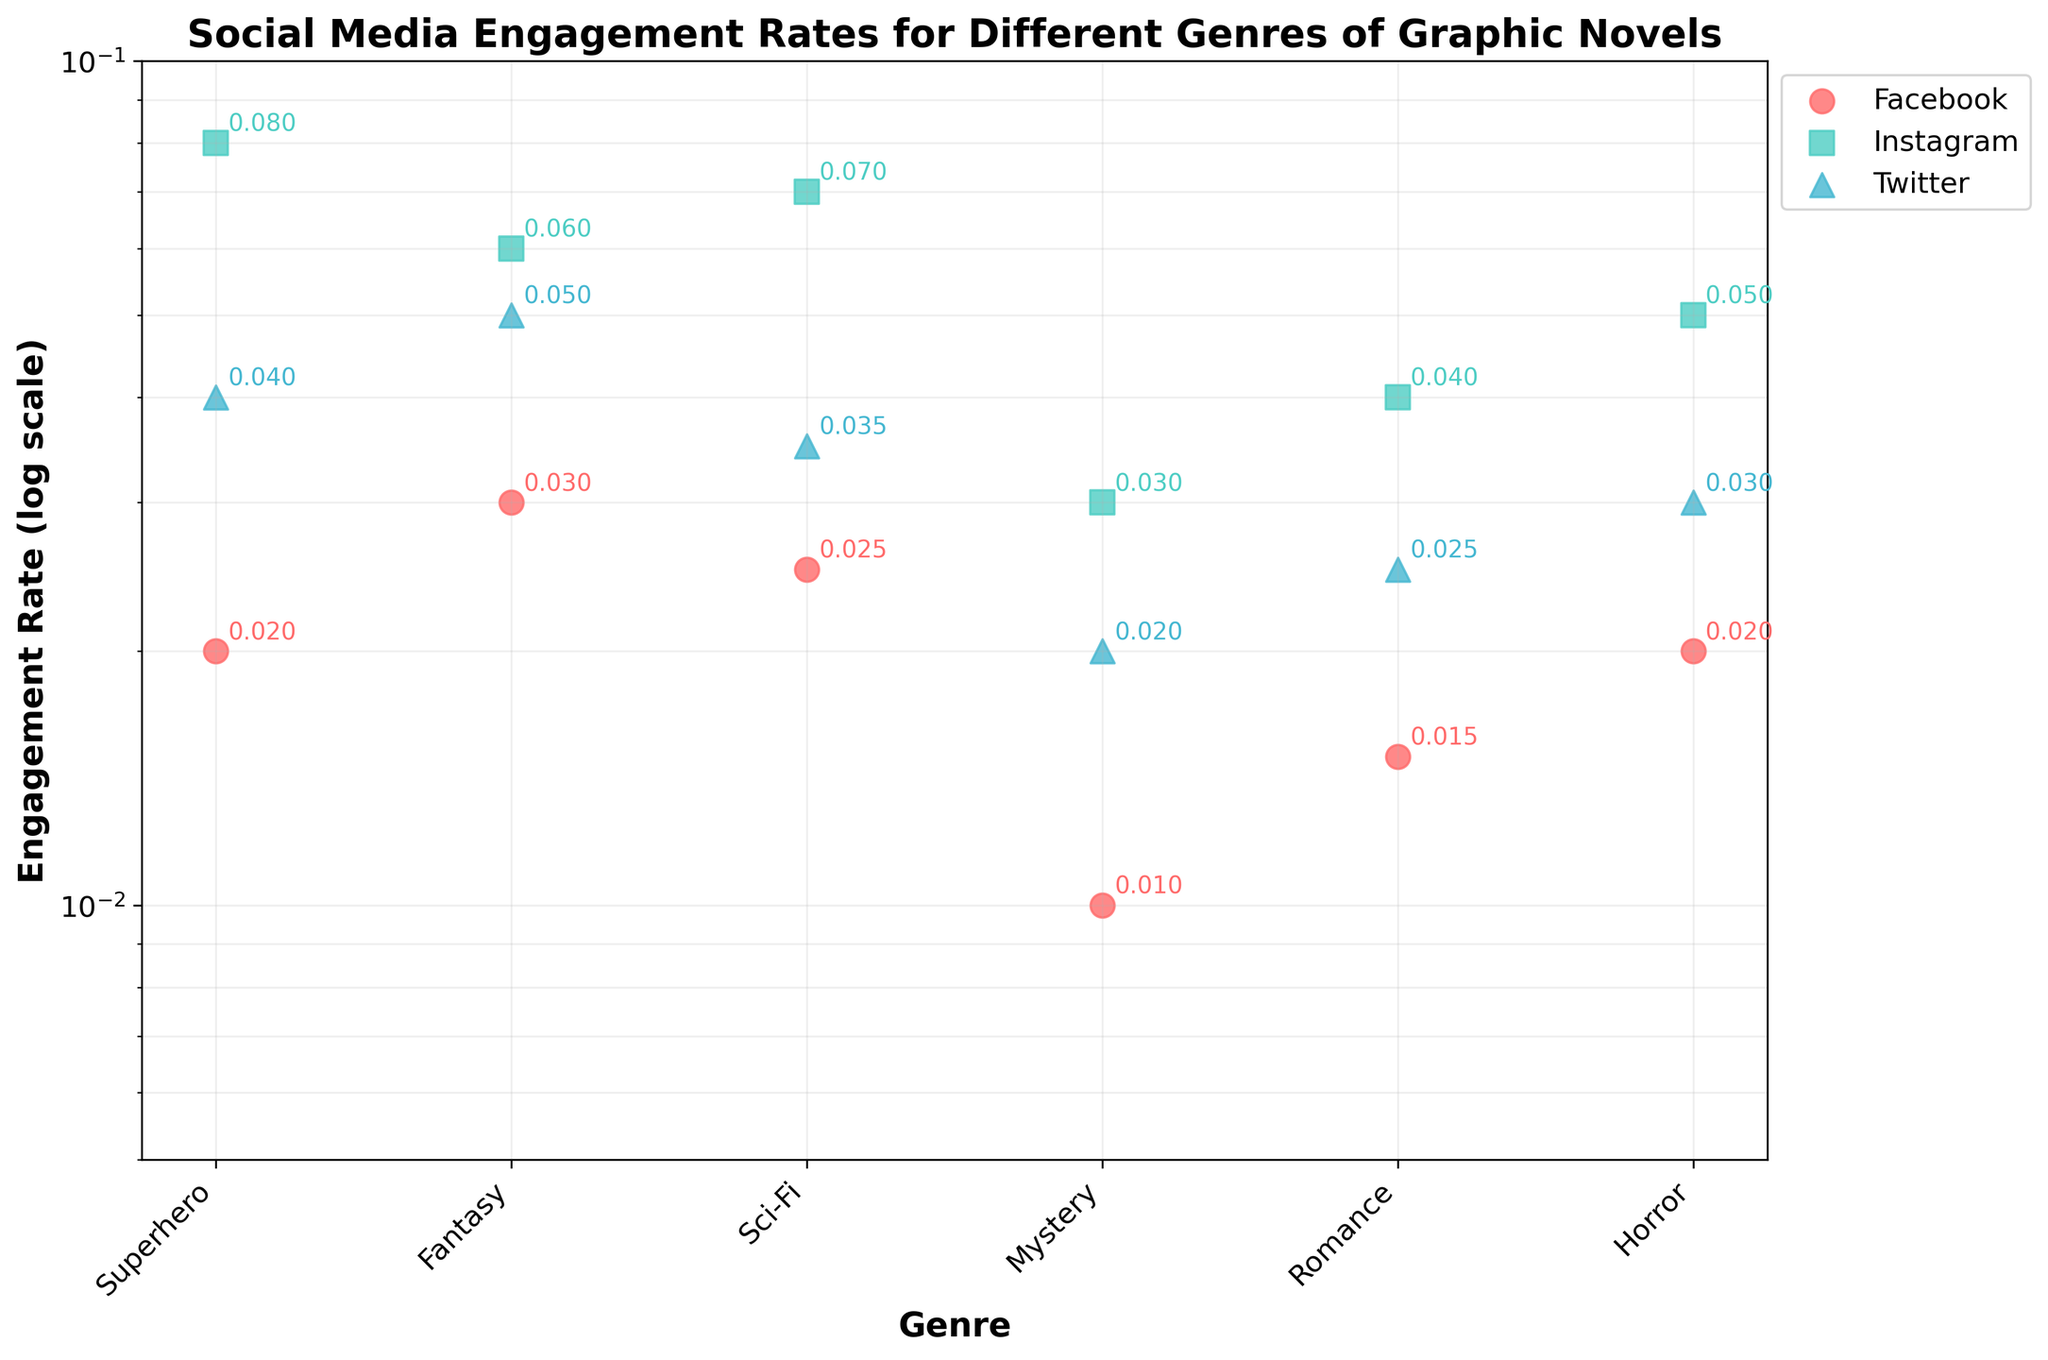Which genre has the highest engagement rate on Instagram? Look at the data points labeled "Instagram" and find the highest point on the Instagram series. The highest engagement rate for Instagram is for the Superhero genre.
Answer: Superhero What is the engagement rate for the Mystery genre on Facebook? Locate the data point associated with the Mystery genre within the Facebook series. The engagement rate for Mystery on Facebook is 0.01.
Answer: 0.01 Which platform has the lowest engagement rate for the Romance genre? Compare the engagement rates of the Romance genre across all three platforms. The platform with the lowest engagement rate for Romance is Facebook with a rate of 0.015.
Answer: Facebook By how much does the engagement rate differ between Sci-Fi on Instagram and Twitter? Find the engagement rates for Sci-Fi on both Instagram (0.07) and Twitter (0.035), then compute the difference (0.07 - 0.035). The difference is 0.035.
Answer: 0.035 What is the median engagement rate for the Fantasy genre across all platforms? To find the median, list the engagement rates of Fantasy for Facebook (0.03), Instagram (0.06), and Twitter (0.05). The values in ascending order are 0.03, 0.05, 0.06. The median value is the middle one, 0.05.
Answer: 0.05 Which platform shows a higher average engagement rate among all genres, Facebook or Twitter? Calculate the average engagement rates for each platform. For Facebook: (0.02 + 0.03 + 0.025 + 0.01 + 0.015 + 0.02) / 6 = 0.02. For Twitter: (0.04 + 0.05 + 0.035 + 0.02 + 0.025 + 0.03) / 6 ≈ 0.0333. Twitter's average is higher.
Answer: Twitter What is the range of engagement rates on Facebook for all genres? Identify the lowest (0.01 for Mystery) and highest (0.03 for Fantasy) engagement rates on Facebook, then compute the range (0.03 - 0.01). The range is 0.02.
Answer: 0.02 Which genre shows the smallest engagement rate discrepancy between different platforms? Compare the engagement rates across three platforms for each genre to find the smallest variation. Romance shows the smallest discrepancy with rates: 0.015 (Facebook), 0.04 (Instagram), and 0.025 (Twitter), having a maximum difference of 0.025.
Answer: Romance 